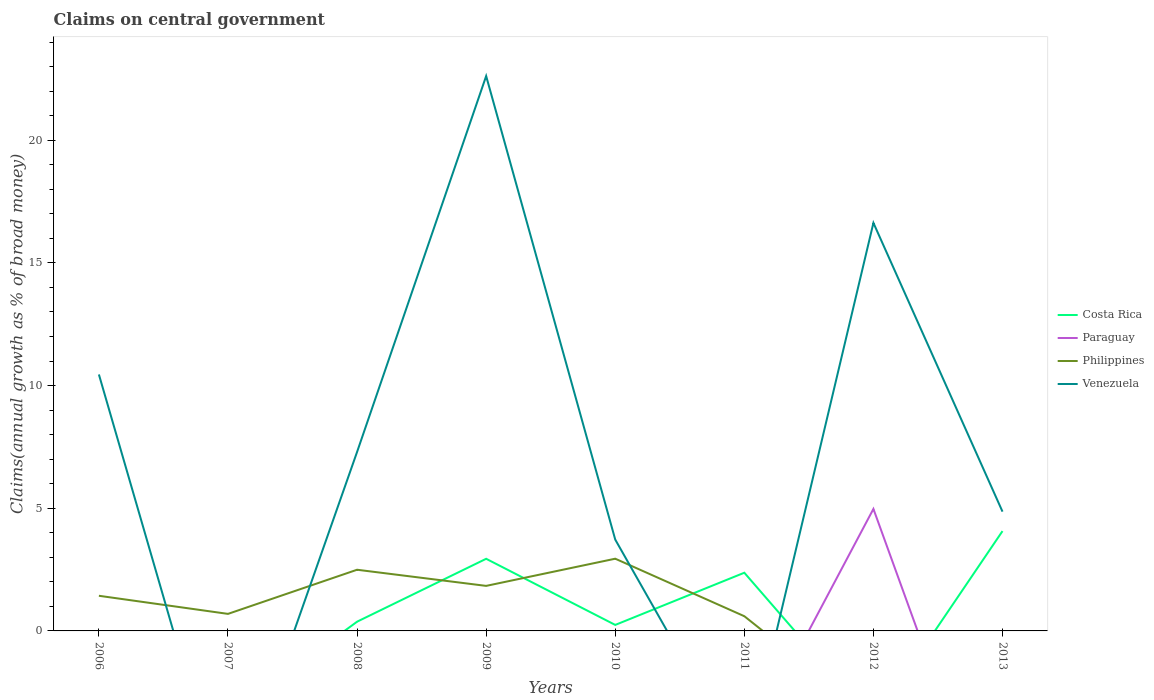Does the line corresponding to Philippines intersect with the line corresponding to Venezuela?
Offer a very short reply. Yes. Is the number of lines equal to the number of legend labels?
Make the answer very short. No. What is the total percentage of broad money claimed on centeral government in Venezuela in the graph?
Your answer should be very brief. 3.16. What is the difference between the highest and the second highest percentage of broad money claimed on centeral government in Costa Rica?
Give a very brief answer. 4.07. What is the difference between the highest and the lowest percentage of broad money claimed on centeral government in Venezuela?
Your response must be concise. 3. Is the percentage of broad money claimed on centeral government in Paraguay strictly greater than the percentage of broad money claimed on centeral government in Costa Rica over the years?
Your response must be concise. No. How many lines are there?
Ensure brevity in your answer.  4. How many years are there in the graph?
Provide a succinct answer. 8. What is the difference between two consecutive major ticks on the Y-axis?
Ensure brevity in your answer.  5. Are the values on the major ticks of Y-axis written in scientific E-notation?
Provide a succinct answer. No. Does the graph contain any zero values?
Ensure brevity in your answer.  Yes. Where does the legend appear in the graph?
Keep it short and to the point. Center right. What is the title of the graph?
Ensure brevity in your answer.  Claims on central government. What is the label or title of the X-axis?
Your answer should be compact. Years. What is the label or title of the Y-axis?
Give a very brief answer. Claims(annual growth as % of broad money). What is the Claims(annual growth as % of broad money) of Costa Rica in 2006?
Offer a terse response. 0. What is the Claims(annual growth as % of broad money) of Philippines in 2006?
Your answer should be compact. 1.43. What is the Claims(annual growth as % of broad money) of Venezuela in 2006?
Give a very brief answer. 10.45. What is the Claims(annual growth as % of broad money) of Paraguay in 2007?
Offer a terse response. 0. What is the Claims(annual growth as % of broad money) in Philippines in 2007?
Make the answer very short. 0.69. What is the Claims(annual growth as % of broad money) in Venezuela in 2007?
Provide a short and direct response. 0. What is the Claims(annual growth as % of broad money) in Costa Rica in 2008?
Keep it short and to the point. 0.38. What is the Claims(annual growth as % of broad money) of Paraguay in 2008?
Offer a terse response. 0. What is the Claims(annual growth as % of broad money) in Philippines in 2008?
Keep it short and to the point. 2.49. What is the Claims(annual growth as % of broad money) of Venezuela in 2008?
Provide a succinct answer. 7.29. What is the Claims(annual growth as % of broad money) in Costa Rica in 2009?
Offer a very short reply. 2.94. What is the Claims(annual growth as % of broad money) of Paraguay in 2009?
Keep it short and to the point. 0. What is the Claims(annual growth as % of broad money) of Philippines in 2009?
Your response must be concise. 1.84. What is the Claims(annual growth as % of broad money) in Venezuela in 2009?
Provide a short and direct response. 22.61. What is the Claims(annual growth as % of broad money) in Costa Rica in 2010?
Keep it short and to the point. 0.24. What is the Claims(annual growth as % of broad money) in Philippines in 2010?
Offer a very short reply. 2.94. What is the Claims(annual growth as % of broad money) in Venezuela in 2010?
Your answer should be very brief. 3.72. What is the Claims(annual growth as % of broad money) in Costa Rica in 2011?
Your response must be concise. 2.37. What is the Claims(annual growth as % of broad money) in Philippines in 2011?
Give a very brief answer. 0.6. What is the Claims(annual growth as % of broad money) in Venezuela in 2011?
Provide a short and direct response. 0. What is the Claims(annual growth as % of broad money) in Costa Rica in 2012?
Offer a very short reply. 0. What is the Claims(annual growth as % of broad money) of Paraguay in 2012?
Keep it short and to the point. 4.97. What is the Claims(annual growth as % of broad money) in Venezuela in 2012?
Ensure brevity in your answer.  16.63. What is the Claims(annual growth as % of broad money) in Costa Rica in 2013?
Ensure brevity in your answer.  4.07. What is the Claims(annual growth as % of broad money) of Paraguay in 2013?
Offer a very short reply. 0. What is the Claims(annual growth as % of broad money) in Philippines in 2013?
Keep it short and to the point. 0. What is the Claims(annual growth as % of broad money) of Venezuela in 2013?
Your response must be concise. 4.86. Across all years, what is the maximum Claims(annual growth as % of broad money) in Costa Rica?
Provide a succinct answer. 4.07. Across all years, what is the maximum Claims(annual growth as % of broad money) of Paraguay?
Ensure brevity in your answer.  4.97. Across all years, what is the maximum Claims(annual growth as % of broad money) of Philippines?
Make the answer very short. 2.94. Across all years, what is the maximum Claims(annual growth as % of broad money) in Venezuela?
Provide a short and direct response. 22.61. Across all years, what is the minimum Claims(annual growth as % of broad money) of Costa Rica?
Your response must be concise. 0. Across all years, what is the minimum Claims(annual growth as % of broad money) of Philippines?
Provide a short and direct response. 0. What is the total Claims(annual growth as % of broad money) of Costa Rica in the graph?
Give a very brief answer. 10. What is the total Claims(annual growth as % of broad money) of Paraguay in the graph?
Provide a succinct answer. 4.97. What is the total Claims(annual growth as % of broad money) of Philippines in the graph?
Your response must be concise. 10. What is the total Claims(annual growth as % of broad money) in Venezuela in the graph?
Your answer should be compact. 65.57. What is the difference between the Claims(annual growth as % of broad money) of Philippines in 2006 and that in 2007?
Your answer should be compact. 0.74. What is the difference between the Claims(annual growth as % of broad money) in Philippines in 2006 and that in 2008?
Keep it short and to the point. -1.06. What is the difference between the Claims(annual growth as % of broad money) in Venezuela in 2006 and that in 2008?
Provide a short and direct response. 3.16. What is the difference between the Claims(annual growth as % of broad money) in Philippines in 2006 and that in 2009?
Your answer should be very brief. -0.4. What is the difference between the Claims(annual growth as % of broad money) of Venezuela in 2006 and that in 2009?
Your answer should be very brief. -12.16. What is the difference between the Claims(annual growth as % of broad money) of Philippines in 2006 and that in 2010?
Ensure brevity in your answer.  -1.51. What is the difference between the Claims(annual growth as % of broad money) of Venezuela in 2006 and that in 2010?
Make the answer very short. 6.73. What is the difference between the Claims(annual growth as % of broad money) in Philippines in 2006 and that in 2011?
Offer a terse response. 0.83. What is the difference between the Claims(annual growth as % of broad money) of Venezuela in 2006 and that in 2012?
Your answer should be compact. -6.18. What is the difference between the Claims(annual growth as % of broad money) of Venezuela in 2006 and that in 2013?
Make the answer very short. 5.59. What is the difference between the Claims(annual growth as % of broad money) of Philippines in 2007 and that in 2008?
Offer a very short reply. -1.8. What is the difference between the Claims(annual growth as % of broad money) in Philippines in 2007 and that in 2009?
Ensure brevity in your answer.  -1.14. What is the difference between the Claims(annual growth as % of broad money) in Philippines in 2007 and that in 2010?
Give a very brief answer. -2.25. What is the difference between the Claims(annual growth as % of broad money) in Philippines in 2007 and that in 2011?
Your response must be concise. 0.09. What is the difference between the Claims(annual growth as % of broad money) of Costa Rica in 2008 and that in 2009?
Give a very brief answer. -2.56. What is the difference between the Claims(annual growth as % of broad money) of Philippines in 2008 and that in 2009?
Give a very brief answer. 0.66. What is the difference between the Claims(annual growth as % of broad money) of Venezuela in 2008 and that in 2009?
Offer a very short reply. -15.32. What is the difference between the Claims(annual growth as % of broad money) of Costa Rica in 2008 and that in 2010?
Offer a terse response. 0.13. What is the difference between the Claims(annual growth as % of broad money) of Philippines in 2008 and that in 2010?
Offer a very short reply. -0.45. What is the difference between the Claims(annual growth as % of broad money) in Venezuela in 2008 and that in 2010?
Your response must be concise. 3.57. What is the difference between the Claims(annual growth as % of broad money) of Costa Rica in 2008 and that in 2011?
Keep it short and to the point. -2. What is the difference between the Claims(annual growth as % of broad money) of Philippines in 2008 and that in 2011?
Ensure brevity in your answer.  1.89. What is the difference between the Claims(annual growth as % of broad money) of Venezuela in 2008 and that in 2012?
Provide a succinct answer. -9.34. What is the difference between the Claims(annual growth as % of broad money) in Costa Rica in 2008 and that in 2013?
Your answer should be very brief. -3.69. What is the difference between the Claims(annual growth as % of broad money) of Venezuela in 2008 and that in 2013?
Offer a very short reply. 2.43. What is the difference between the Claims(annual growth as % of broad money) in Costa Rica in 2009 and that in 2010?
Keep it short and to the point. 2.7. What is the difference between the Claims(annual growth as % of broad money) in Philippines in 2009 and that in 2010?
Offer a very short reply. -1.11. What is the difference between the Claims(annual growth as % of broad money) of Venezuela in 2009 and that in 2010?
Give a very brief answer. 18.89. What is the difference between the Claims(annual growth as % of broad money) of Costa Rica in 2009 and that in 2011?
Your answer should be compact. 0.57. What is the difference between the Claims(annual growth as % of broad money) in Philippines in 2009 and that in 2011?
Ensure brevity in your answer.  1.24. What is the difference between the Claims(annual growth as % of broad money) in Venezuela in 2009 and that in 2012?
Provide a short and direct response. 5.98. What is the difference between the Claims(annual growth as % of broad money) in Costa Rica in 2009 and that in 2013?
Your answer should be very brief. -1.13. What is the difference between the Claims(annual growth as % of broad money) of Venezuela in 2009 and that in 2013?
Your answer should be very brief. 17.75. What is the difference between the Claims(annual growth as % of broad money) in Costa Rica in 2010 and that in 2011?
Make the answer very short. -2.13. What is the difference between the Claims(annual growth as % of broad money) in Philippines in 2010 and that in 2011?
Give a very brief answer. 2.34. What is the difference between the Claims(annual growth as % of broad money) of Venezuela in 2010 and that in 2012?
Your answer should be very brief. -12.91. What is the difference between the Claims(annual growth as % of broad money) in Costa Rica in 2010 and that in 2013?
Keep it short and to the point. -3.82. What is the difference between the Claims(annual growth as % of broad money) in Venezuela in 2010 and that in 2013?
Provide a short and direct response. -1.14. What is the difference between the Claims(annual growth as % of broad money) in Costa Rica in 2011 and that in 2013?
Keep it short and to the point. -1.7. What is the difference between the Claims(annual growth as % of broad money) in Venezuela in 2012 and that in 2013?
Your answer should be very brief. 11.77. What is the difference between the Claims(annual growth as % of broad money) in Philippines in 2006 and the Claims(annual growth as % of broad money) in Venezuela in 2008?
Offer a very short reply. -5.86. What is the difference between the Claims(annual growth as % of broad money) of Philippines in 2006 and the Claims(annual growth as % of broad money) of Venezuela in 2009?
Keep it short and to the point. -21.18. What is the difference between the Claims(annual growth as % of broad money) in Philippines in 2006 and the Claims(annual growth as % of broad money) in Venezuela in 2010?
Ensure brevity in your answer.  -2.29. What is the difference between the Claims(annual growth as % of broad money) of Philippines in 2006 and the Claims(annual growth as % of broad money) of Venezuela in 2012?
Ensure brevity in your answer.  -15.2. What is the difference between the Claims(annual growth as % of broad money) in Philippines in 2006 and the Claims(annual growth as % of broad money) in Venezuela in 2013?
Make the answer very short. -3.43. What is the difference between the Claims(annual growth as % of broad money) in Philippines in 2007 and the Claims(annual growth as % of broad money) in Venezuela in 2008?
Ensure brevity in your answer.  -6.6. What is the difference between the Claims(annual growth as % of broad money) of Philippines in 2007 and the Claims(annual growth as % of broad money) of Venezuela in 2009?
Provide a succinct answer. -21.92. What is the difference between the Claims(annual growth as % of broad money) of Philippines in 2007 and the Claims(annual growth as % of broad money) of Venezuela in 2010?
Offer a terse response. -3.03. What is the difference between the Claims(annual growth as % of broad money) in Philippines in 2007 and the Claims(annual growth as % of broad money) in Venezuela in 2012?
Offer a very short reply. -15.93. What is the difference between the Claims(annual growth as % of broad money) of Philippines in 2007 and the Claims(annual growth as % of broad money) of Venezuela in 2013?
Keep it short and to the point. -4.17. What is the difference between the Claims(annual growth as % of broad money) in Costa Rica in 2008 and the Claims(annual growth as % of broad money) in Philippines in 2009?
Offer a terse response. -1.46. What is the difference between the Claims(annual growth as % of broad money) in Costa Rica in 2008 and the Claims(annual growth as % of broad money) in Venezuela in 2009?
Your response must be concise. -22.24. What is the difference between the Claims(annual growth as % of broad money) in Philippines in 2008 and the Claims(annual growth as % of broad money) in Venezuela in 2009?
Make the answer very short. -20.12. What is the difference between the Claims(annual growth as % of broad money) in Costa Rica in 2008 and the Claims(annual growth as % of broad money) in Philippines in 2010?
Offer a terse response. -2.57. What is the difference between the Claims(annual growth as % of broad money) in Costa Rica in 2008 and the Claims(annual growth as % of broad money) in Venezuela in 2010?
Make the answer very short. -3.35. What is the difference between the Claims(annual growth as % of broad money) in Philippines in 2008 and the Claims(annual growth as % of broad money) in Venezuela in 2010?
Your answer should be very brief. -1.23. What is the difference between the Claims(annual growth as % of broad money) of Costa Rica in 2008 and the Claims(annual growth as % of broad money) of Philippines in 2011?
Keep it short and to the point. -0.22. What is the difference between the Claims(annual growth as % of broad money) in Costa Rica in 2008 and the Claims(annual growth as % of broad money) in Paraguay in 2012?
Keep it short and to the point. -4.6. What is the difference between the Claims(annual growth as % of broad money) in Costa Rica in 2008 and the Claims(annual growth as % of broad money) in Venezuela in 2012?
Provide a short and direct response. -16.25. What is the difference between the Claims(annual growth as % of broad money) in Philippines in 2008 and the Claims(annual growth as % of broad money) in Venezuela in 2012?
Make the answer very short. -14.14. What is the difference between the Claims(annual growth as % of broad money) in Costa Rica in 2008 and the Claims(annual growth as % of broad money) in Venezuela in 2013?
Your answer should be very brief. -4.49. What is the difference between the Claims(annual growth as % of broad money) of Philippines in 2008 and the Claims(annual growth as % of broad money) of Venezuela in 2013?
Give a very brief answer. -2.37. What is the difference between the Claims(annual growth as % of broad money) of Costa Rica in 2009 and the Claims(annual growth as % of broad money) of Philippines in 2010?
Make the answer very short. -0. What is the difference between the Claims(annual growth as % of broad money) in Costa Rica in 2009 and the Claims(annual growth as % of broad money) in Venezuela in 2010?
Offer a very short reply. -0.78. What is the difference between the Claims(annual growth as % of broad money) of Philippines in 2009 and the Claims(annual growth as % of broad money) of Venezuela in 2010?
Provide a succinct answer. -1.89. What is the difference between the Claims(annual growth as % of broad money) in Costa Rica in 2009 and the Claims(annual growth as % of broad money) in Philippines in 2011?
Your answer should be compact. 2.34. What is the difference between the Claims(annual growth as % of broad money) in Costa Rica in 2009 and the Claims(annual growth as % of broad money) in Paraguay in 2012?
Your response must be concise. -2.03. What is the difference between the Claims(annual growth as % of broad money) of Costa Rica in 2009 and the Claims(annual growth as % of broad money) of Venezuela in 2012?
Provide a succinct answer. -13.69. What is the difference between the Claims(annual growth as % of broad money) in Philippines in 2009 and the Claims(annual growth as % of broad money) in Venezuela in 2012?
Your answer should be compact. -14.79. What is the difference between the Claims(annual growth as % of broad money) in Costa Rica in 2009 and the Claims(annual growth as % of broad money) in Venezuela in 2013?
Ensure brevity in your answer.  -1.92. What is the difference between the Claims(annual growth as % of broad money) of Philippines in 2009 and the Claims(annual growth as % of broad money) of Venezuela in 2013?
Give a very brief answer. -3.03. What is the difference between the Claims(annual growth as % of broad money) of Costa Rica in 2010 and the Claims(annual growth as % of broad money) of Philippines in 2011?
Provide a short and direct response. -0.36. What is the difference between the Claims(annual growth as % of broad money) of Costa Rica in 2010 and the Claims(annual growth as % of broad money) of Paraguay in 2012?
Offer a very short reply. -4.73. What is the difference between the Claims(annual growth as % of broad money) in Costa Rica in 2010 and the Claims(annual growth as % of broad money) in Venezuela in 2012?
Your response must be concise. -16.38. What is the difference between the Claims(annual growth as % of broad money) of Philippines in 2010 and the Claims(annual growth as % of broad money) of Venezuela in 2012?
Your answer should be compact. -13.69. What is the difference between the Claims(annual growth as % of broad money) of Costa Rica in 2010 and the Claims(annual growth as % of broad money) of Venezuela in 2013?
Give a very brief answer. -4.62. What is the difference between the Claims(annual growth as % of broad money) in Philippines in 2010 and the Claims(annual growth as % of broad money) in Venezuela in 2013?
Provide a short and direct response. -1.92. What is the difference between the Claims(annual growth as % of broad money) in Costa Rica in 2011 and the Claims(annual growth as % of broad money) in Paraguay in 2012?
Your answer should be very brief. -2.6. What is the difference between the Claims(annual growth as % of broad money) in Costa Rica in 2011 and the Claims(annual growth as % of broad money) in Venezuela in 2012?
Your answer should be compact. -14.26. What is the difference between the Claims(annual growth as % of broad money) in Philippines in 2011 and the Claims(annual growth as % of broad money) in Venezuela in 2012?
Offer a terse response. -16.03. What is the difference between the Claims(annual growth as % of broad money) of Costa Rica in 2011 and the Claims(annual growth as % of broad money) of Venezuela in 2013?
Provide a succinct answer. -2.49. What is the difference between the Claims(annual growth as % of broad money) of Philippines in 2011 and the Claims(annual growth as % of broad money) of Venezuela in 2013?
Ensure brevity in your answer.  -4.26. What is the difference between the Claims(annual growth as % of broad money) of Paraguay in 2012 and the Claims(annual growth as % of broad money) of Venezuela in 2013?
Provide a short and direct response. 0.11. What is the average Claims(annual growth as % of broad money) in Costa Rica per year?
Offer a very short reply. 1.25. What is the average Claims(annual growth as % of broad money) in Paraguay per year?
Offer a very short reply. 0.62. What is the average Claims(annual growth as % of broad money) of Philippines per year?
Make the answer very short. 1.25. What is the average Claims(annual growth as % of broad money) of Venezuela per year?
Offer a very short reply. 8.2. In the year 2006, what is the difference between the Claims(annual growth as % of broad money) of Philippines and Claims(annual growth as % of broad money) of Venezuela?
Your answer should be very brief. -9.02. In the year 2008, what is the difference between the Claims(annual growth as % of broad money) of Costa Rica and Claims(annual growth as % of broad money) of Philippines?
Ensure brevity in your answer.  -2.12. In the year 2008, what is the difference between the Claims(annual growth as % of broad money) of Costa Rica and Claims(annual growth as % of broad money) of Venezuela?
Your response must be concise. -6.92. In the year 2008, what is the difference between the Claims(annual growth as % of broad money) in Philippines and Claims(annual growth as % of broad money) in Venezuela?
Make the answer very short. -4.8. In the year 2009, what is the difference between the Claims(annual growth as % of broad money) in Costa Rica and Claims(annual growth as % of broad money) in Philippines?
Your response must be concise. 1.1. In the year 2009, what is the difference between the Claims(annual growth as % of broad money) of Costa Rica and Claims(annual growth as % of broad money) of Venezuela?
Keep it short and to the point. -19.67. In the year 2009, what is the difference between the Claims(annual growth as % of broad money) of Philippines and Claims(annual growth as % of broad money) of Venezuela?
Keep it short and to the point. -20.78. In the year 2010, what is the difference between the Claims(annual growth as % of broad money) in Costa Rica and Claims(annual growth as % of broad money) in Philippines?
Give a very brief answer. -2.7. In the year 2010, what is the difference between the Claims(annual growth as % of broad money) of Costa Rica and Claims(annual growth as % of broad money) of Venezuela?
Offer a very short reply. -3.48. In the year 2010, what is the difference between the Claims(annual growth as % of broad money) in Philippines and Claims(annual growth as % of broad money) in Venezuela?
Your answer should be compact. -0.78. In the year 2011, what is the difference between the Claims(annual growth as % of broad money) of Costa Rica and Claims(annual growth as % of broad money) of Philippines?
Provide a succinct answer. 1.77. In the year 2012, what is the difference between the Claims(annual growth as % of broad money) in Paraguay and Claims(annual growth as % of broad money) in Venezuela?
Give a very brief answer. -11.66. In the year 2013, what is the difference between the Claims(annual growth as % of broad money) of Costa Rica and Claims(annual growth as % of broad money) of Venezuela?
Give a very brief answer. -0.79. What is the ratio of the Claims(annual growth as % of broad money) of Philippines in 2006 to that in 2007?
Give a very brief answer. 2.06. What is the ratio of the Claims(annual growth as % of broad money) of Philippines in 2006 to that in 2008?
Provide a short and direct response. 0.57. What is the ratio of the Claims(annual growth as % of broad money) of Venezuela in 2006 to that in 2008?
Offer a very short reply. 1.43. What is the ratio of the Claims(annual growth as % of broad money) in Philippines in 2006 to that in 2009?
Offer a very short reply. 0.78. What is the ratio of the Claims(annual growth as % of broad money) of Venezuela in 2006 to that in 2009?
Your answer should be very brief. 0.46. What is the ratio of the Claims(annual growth as % of broad money) of Philippines in 2006 to that in 2010?
Your response must be concise. 0.49. What is the ratio of the Claims(annual growth as % of broad money) of Venezuela in 2006 to that in 2010?
Ensure brevity in your answer.  2.81. What is the ratio of the Claims(annual growth as % of broad money) of Philippines in 2006 to that in 2011?
Give a very brief answer. 2.39. What is the ratio of the Claims(annual growth as % of broad money) in Venezuela in 2006 to that in 2012?
Offer a terse response. 0.63. What is the ratio of the Claims(annual growth as % of broad money) of Venezuela in 2006 to that in 2013?
Make the answer very short. 2.15. What is the ratio of the Claims(annual growth as % of broad money) of Philippines in 2007 to that in 2008?
Your answer should be compact. 0.28. What is the ratio of the Claims(annual growth as % of broad money) of Philippines in 2007 to that in 2009?
Ensure brevity in your answer.  0.38. What is the ratio of the Claims(annual growth as % of broad money) in Philippines in 2007 to that in 2010?
Your answer should be very brief. 0.24. What is the ratio of the Claims(annual growth as % of broad money) of Philippines in 2007 to that in 2011?
Keep it short and to the point. 1.16. What is the ratio of the Claims(annual growth as % of broad money) of Costa Rica in 2008 to that in 2009?
Ensure brevity in your answer.  0.13. What is the ratio of the Claims(annual growth as % of broad money) of Philippines in 2008 to that in 2009?
Offer a very short reply. 1.36. What is the ratio of the Claims(annual growth as % of broad money) of Venezuela in 2008 to that in 2009?
Provide a succinct answer. 0.32. What is the ratio of the Claims(annual growth as % of broad money) of Costa Rica in 2008 to that in 2010?
Offer a terse response. 1.54. What is the ratio of the Claims(annual growth as % of broad money) in Philippines in 2008 to that in 2010?
Make the answer very short. 0.85. What is the ratio of the Claims(annual growth as % of broad money) in Venezuela in 2008 to that in 2010?
Give a very brief answer. 1.96. What is the ratio of the Claims(annual growth as % of broad money) in Costa Rica in 2008 to that in 2011?
Offer a terse response. 0.16. What is the ratio of the Claims(annual growth as % of broad money) in Philippines in 2008 to that in 2011?
Make the answer very short. 4.16. What is the ratio of the Claims(annual growth as % of broad money) in Venezuela in 2008 to that in 2012?
Your response must be concise. 0.44. What is the ratio of the Claims(annual growth as % of broad money) of Costa Rica in 2008 to that in 2013?
Your response must be concise. 0.09. What is the ratio of the Claims(annual growth as % of broad money) in Venezuela in 2008 to that in 2013?
Offer a terse response. 1.5. What is the ratio of the Claims(annual growth as % of broad money) in Costa Rica in 2009 to that in 2010?
Offer a terse response. 12.02. What is the ratio of the Claims(annual growth as % of broad money) of Philippines in 2009 to that in 2010?
Offer a very short reply. 0.62. What is the ratio of the Claims(annual growth as % of broad money) in Venezuela in 2009 to that in 2010?
Your answer should be very brief. 6.08. What is the ratio of the Claims(annual growth as % of broad money) of Costa Rica in 2009 to that in 2011?
Offer a very short reply. 1.24. What is the ratio of the Claims(annual growth as % of broad money) in Philippines in 2009 to that in 2011?
Your answer should be compact. 3.06. What is the ratio of the Claims(annual growth as % of broad money) in Venezuela in 2009 to that in 2012?
Provide a succinct answer. 1.36. What is the ratio of the Claims(annual growth as % of broad money) of Costa Rica in 2009 to that in 2013?
Your answer should be very brief. 0.72. What is the ratio of the Claims(annual growth as % of broad money) in Venezuela in 2009 to that in 2013?
Your answer should be compact. 4.65. What is the ratio of the Claims(annual growth as % of broad money) of Costa Rica in 2010 to that in 2011?
Offer a very short reply. 0.1. What is the ratio of the Claims(annual growth as % of broad money) in Philippines in 2010 to that in 2011?
Keep it short and to the point. 4.91. What is the ratio of the Claims(annual growth as % of broad money) in Venezuela in 2010 to that in 2012?
Ensure brevity in your answer.  0.22. What is the ratio of the Claims(annual growth as % of broad money) of Costa Rica in 2010 to that in 2013?
Give a very brief answer. 0.06. What is the ratio of the Claims(annual growth as % of broad money) of Venezuela in 2010 to that in 2013?
Your answer should be very brief. 0.77. What is the ratio of the Claims(annual growth as % of broad money) in Costa Rica in 2011 to that in 2013?
Your response must be concise. 0.58. What is the ratio of the Claims(annual growth as % of broad money) of Venezuela in 2012 to that in 2013?
Provide a succinct answer. 3.42. What is the difference between the highest and the second highest Claims(annual growth as % of broad money) in Costa Rica?
Make the answer very short. 1.13. What is the difference between the highest and the second highest Claims(annual growth as % of broad money) in Philippines?
Your answer should be very brief. 0.45. What is the difference between the highest and the second highest Claims(annual growth as % of broad money) in Venezuela?
Provide a succinct answer. 5.98. What is the difference between the highest and the lowest Claims(annual growth as % of broad money) in Costa Rica?
Make the answer very short. 4.07. What is the difference between the highest and the lowest Claims(annual growth as % of broad money) of Paraguay?
Give a very brief answer. 4.97. What is the difference between the highest and the lowest Claims(annual growth as % of broad money) of Philippines?
Make the answer very short. 2.94. What is the difference between the highest and the lowest Claims(annual growth as % of broad money) in Venezuela?
Make the answer very short. 22.61. 